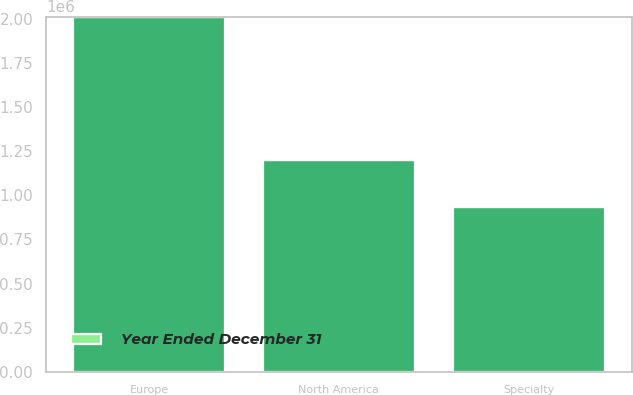<chart> <loc_0><loc_0><loc_500><loc_500><stacked_bar_chart><ecel><fcel>North America<fcel>Europe<fcel>Specialty<nl><fcel>nan<fcel>1.19856e+06<fcel>2.0128e+06<fcel>934119<nl><fcel>Year Ended December 31<fcel>1<fcel>2<fcel>3<nl></chart> 